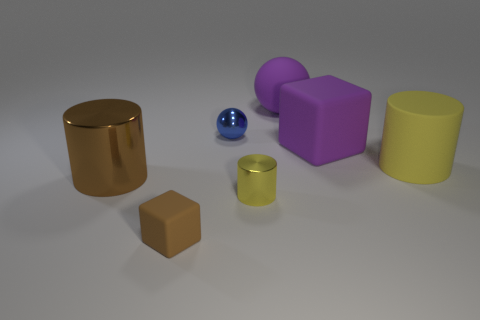Subtract all yellow cylinders. How many were subtracted if there are1yellow cylinders left? 1 Subtract all yellow rubber cylinders. How many cylinders are left? 2 Subtract all cubes. How many objects are left? 5 Subtract 2 cylinders. How many cylinders are left? 1 Add 1 small purple rubber spheres. How many objects exist? 8 Subtract all brown cylinders. How many cylinders are left? 2 Subtract all red cylinders. Subtract all red spheres. How many cylinders are left? 3 Subtract all blue blocks. How many green spheres are left? 0 Subtract all large yellow metal cylinders. Subtract all small yellow shiny things. How many objects are left? 6 Add 5 shiny things. How many shiny things are left? 8 